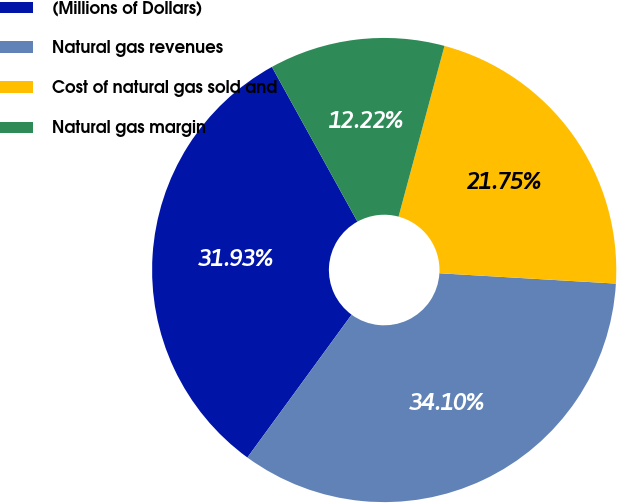<chart> <loc_0><loc_0><loc_500><loc_500><pie_chart><fcel>(Millions of Dollars)<fcel>Natural gas revenues<fcel>Cost of natural gas sold and<fcel>Natural gas margin<nl><fcel>31.93%<fcel>34.1%<fcel>21.75%<fcel>12.22%<nl></chart> 